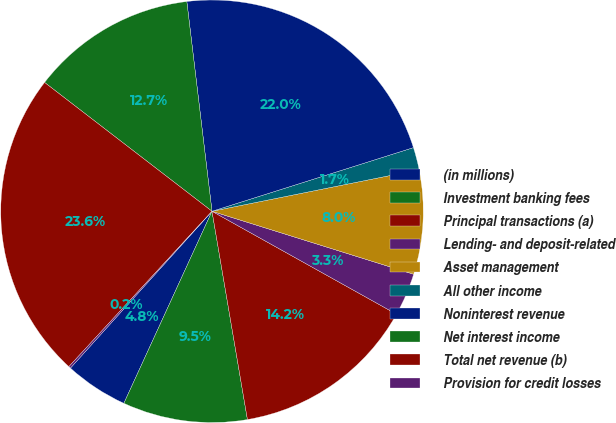<chart> <loc_0><loc_0><loc_500><loc_500><pie_chart><fcel>(in millions)<fcel>Investment banking fees<fcel>Principal transactions (a)<fcel>Lending- and deposit-related<fcel>Asset management<fcel>All other income<fcel>Noninterest revenue<fcel>Net interest income<fcel>Total net revenue (b)<fcel>Provision for credit losses<nl><fcel>4.84%<fcel>9.53%<fcel>14.22%<fcel>3.28%<fcel>7.97%<fcel>1.72%<fcel>22.03%<fcel>12.66%<fcel>23.59%<fcel>0.16%<nl></chart> 